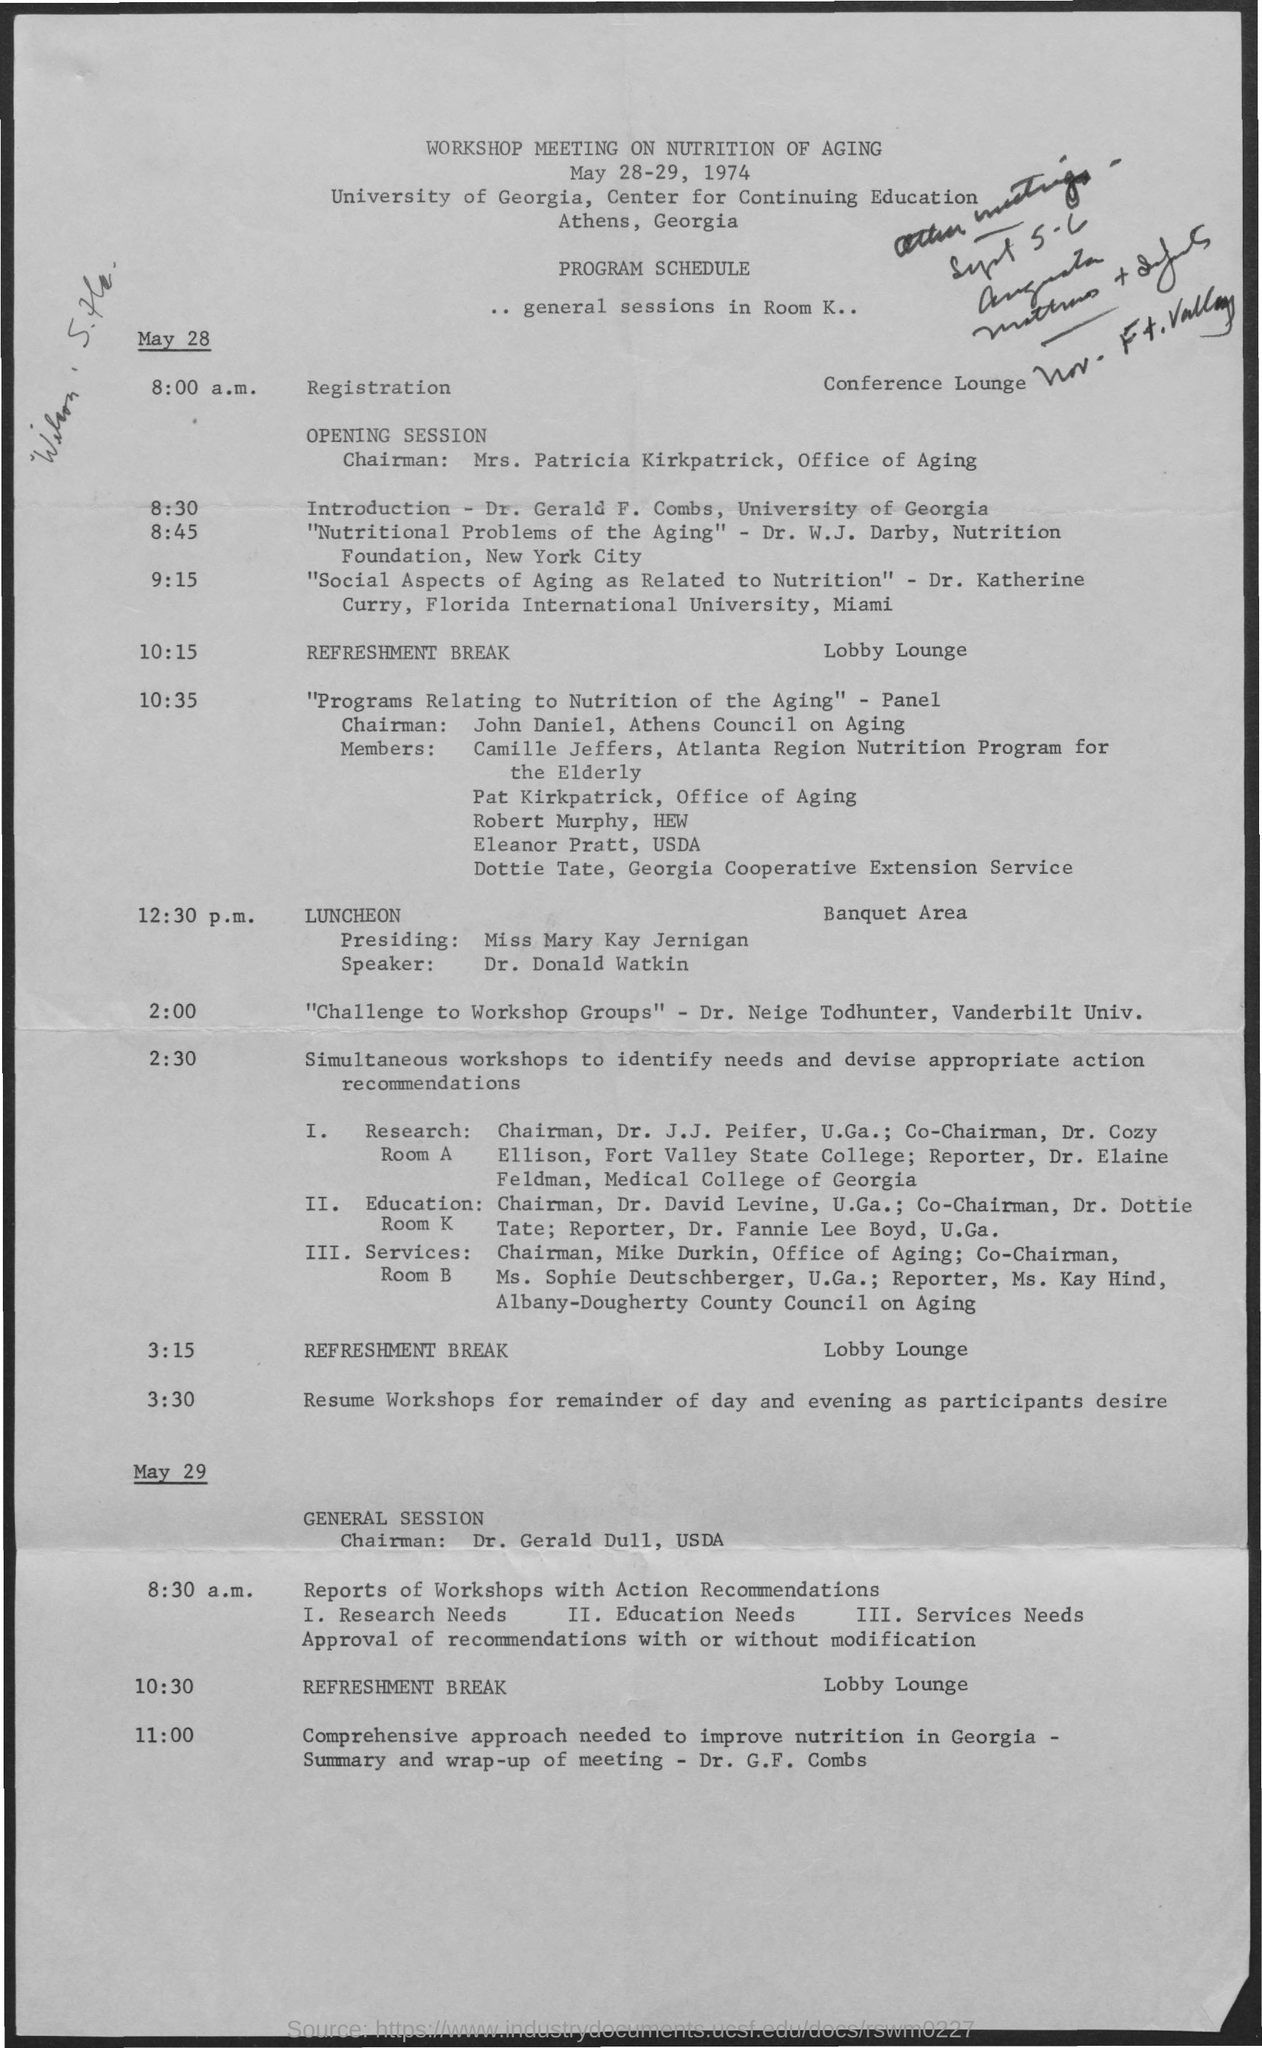Mention a couple of crucial points in this snapshot. Dr. Gerald F. Combs is giving the introduction speech. The workshop will focus on the topic of nutrition in relation to aging. Dr. Katherine Curry, a renowned professor of astrophysics, received her education from Florida International University in Miami. The chairman of the general session on May 29 is Dr. Gerald Dull. 